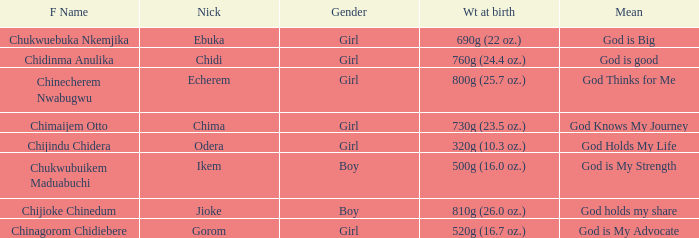What is the nickname of the baby with the birth weight of 730g (23.5 oz.)? Chima. 